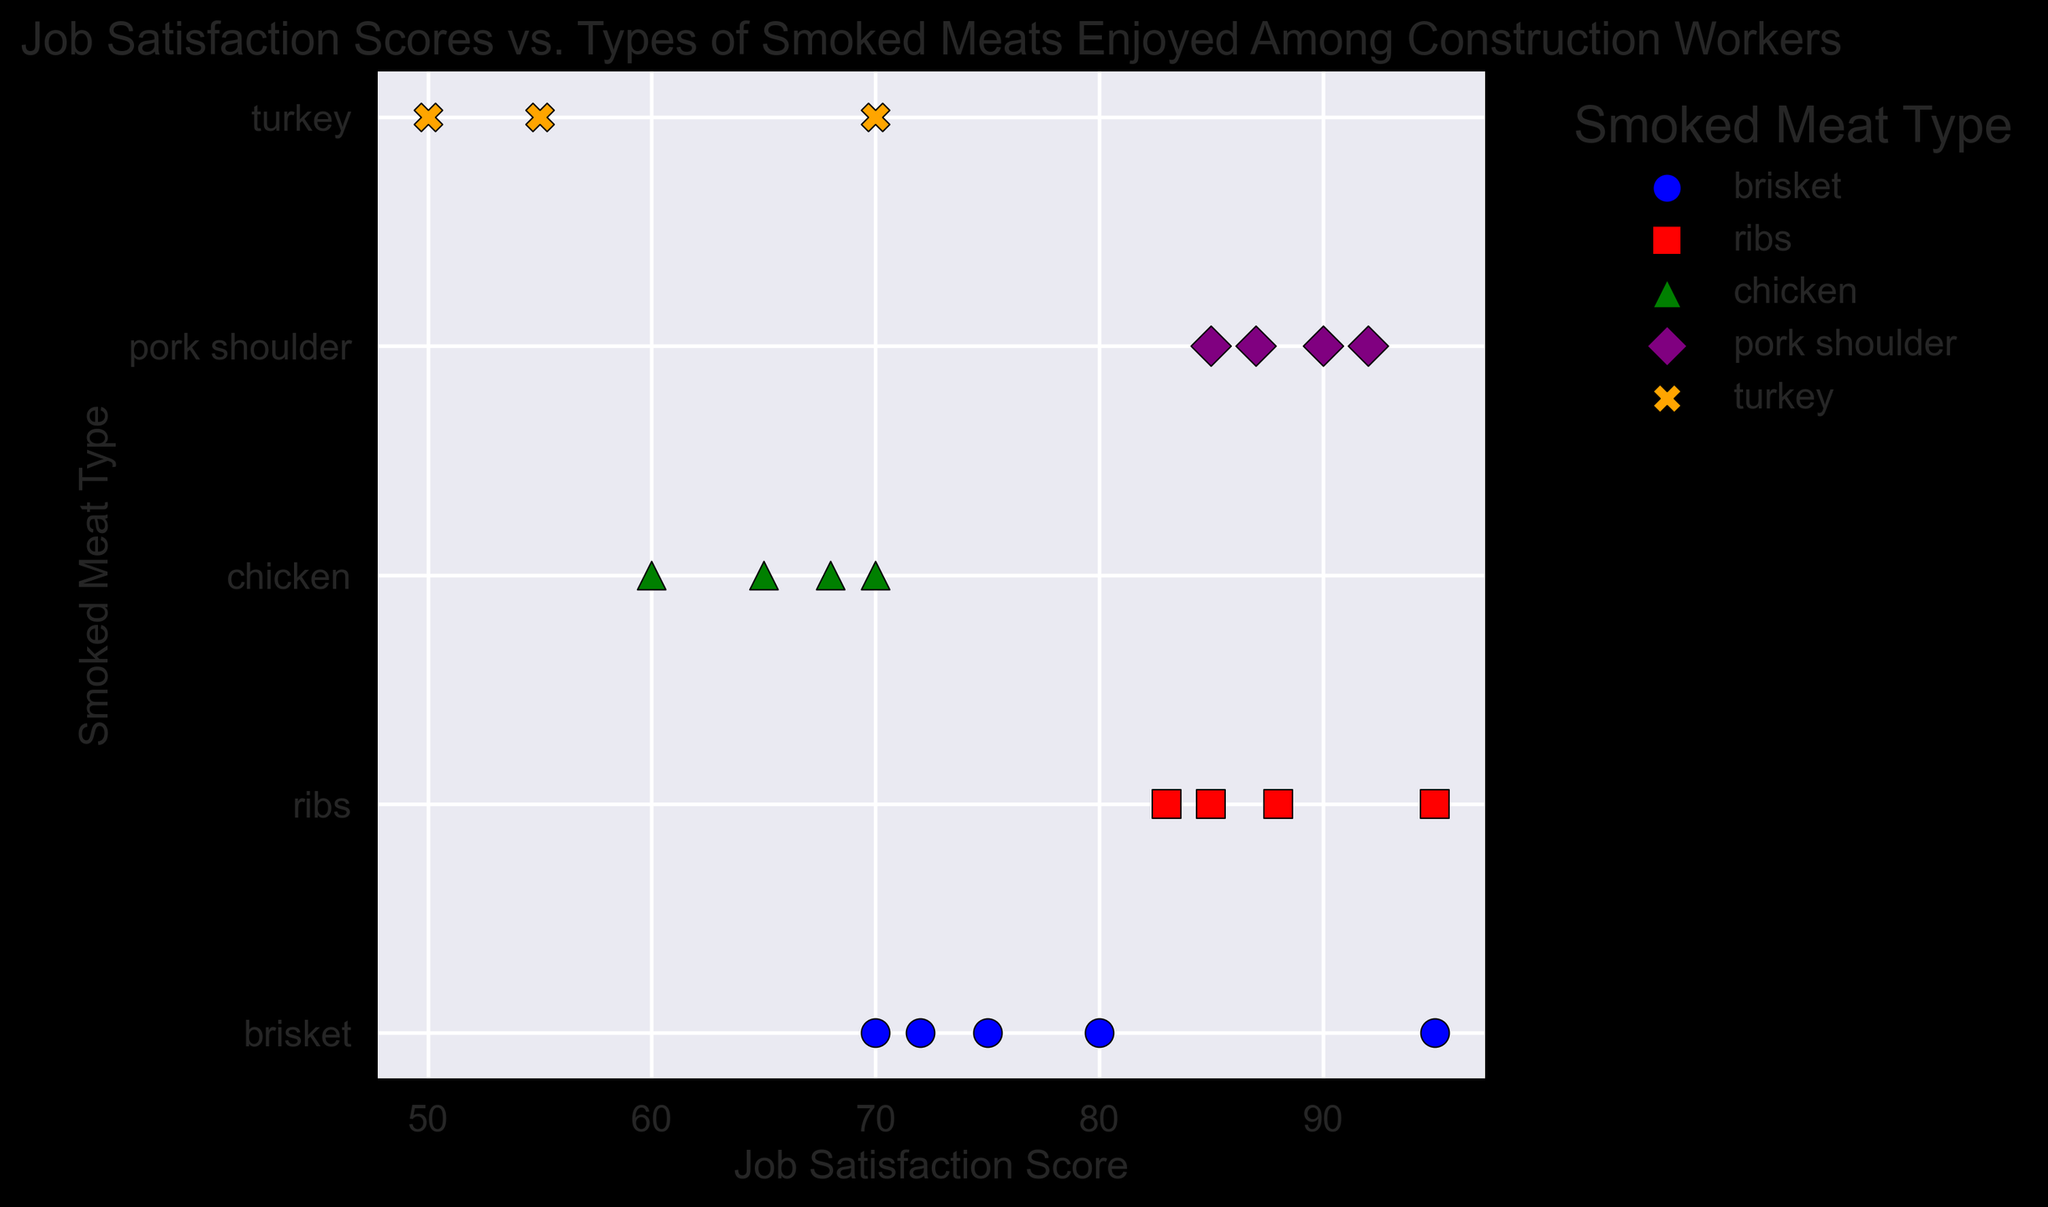What is the highest job satisfaction score observed for ribs? To find the highest job satisfaction score for ribs, look for the maximum y-value where the marker is a red square.
Answer: 95 Which smoked meat type has the lowest recorded job satisfaction score and what is the score? Compare the smallest values along the x-axis for each color and marker. The lowest score is 50 for turkey.
Answer: Turkey, 50 How do the average job satisfaction scores for brisket compare to pork shoulder? Calculate the average scores for each meat type. Brisket: (80+70+75+95+72)/5 = 78.4; Pork shoulder: (90+85+92+87)/4 = 88.5. Compare the averages.
Answer: Pork shoulder has a higher average score than brisket Which smoked meat types have at least one job satisfaction score above 90? Identify the colors and markers on the right side of the plot, where the x-axis values are above 90. Brisket, Ribs, and Pork shoulder have markers above 90.
Answer: Brisket, Ribs, Pork Shoulder What is the range of job satisfaction scores for chicken? Find the minimum and maximum x-axis values where the marker is a green triangle. The range is from 60 to 70.
Answer: 10 (70 - 60) Which smoked meat type has the most consistent job satisfaction scores, i.e., the smallest spread? Compare the difference between the highest and lowest x-axis values for each meat type. Chicken has the smallest range (70-60=10) compared to others.
Answer: Chicken 